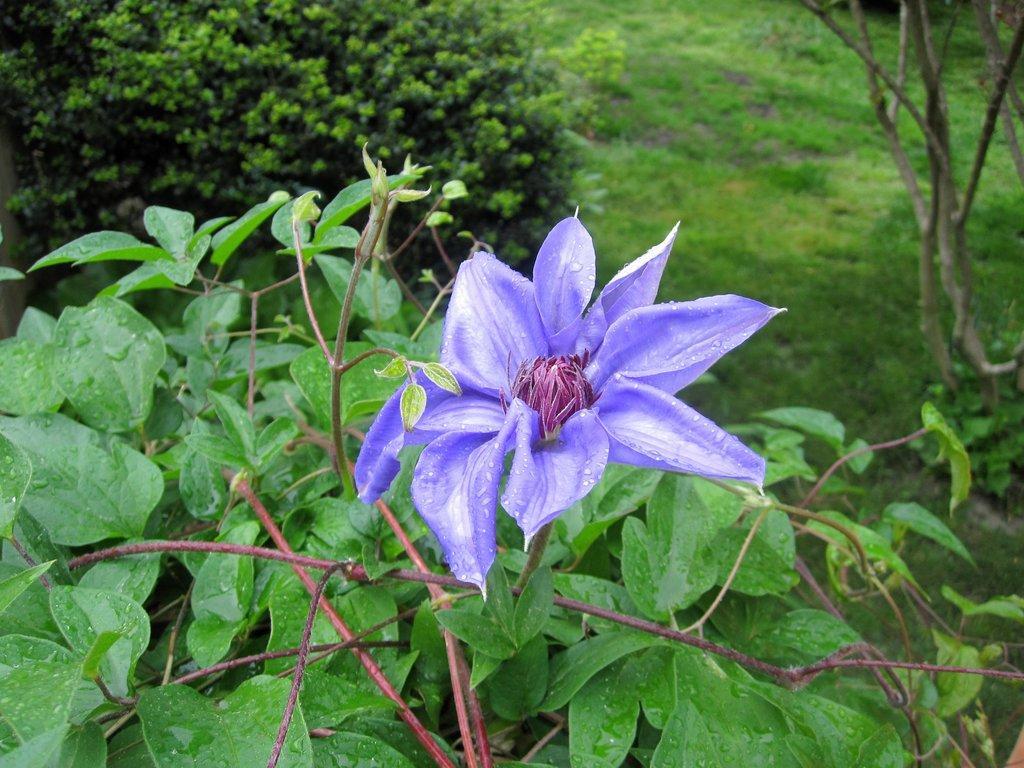Describe this image in one or two sentences. In this image we can see purple color flowers, stems and leaves. We can see plant, grassy land and stems at the top of the image. 